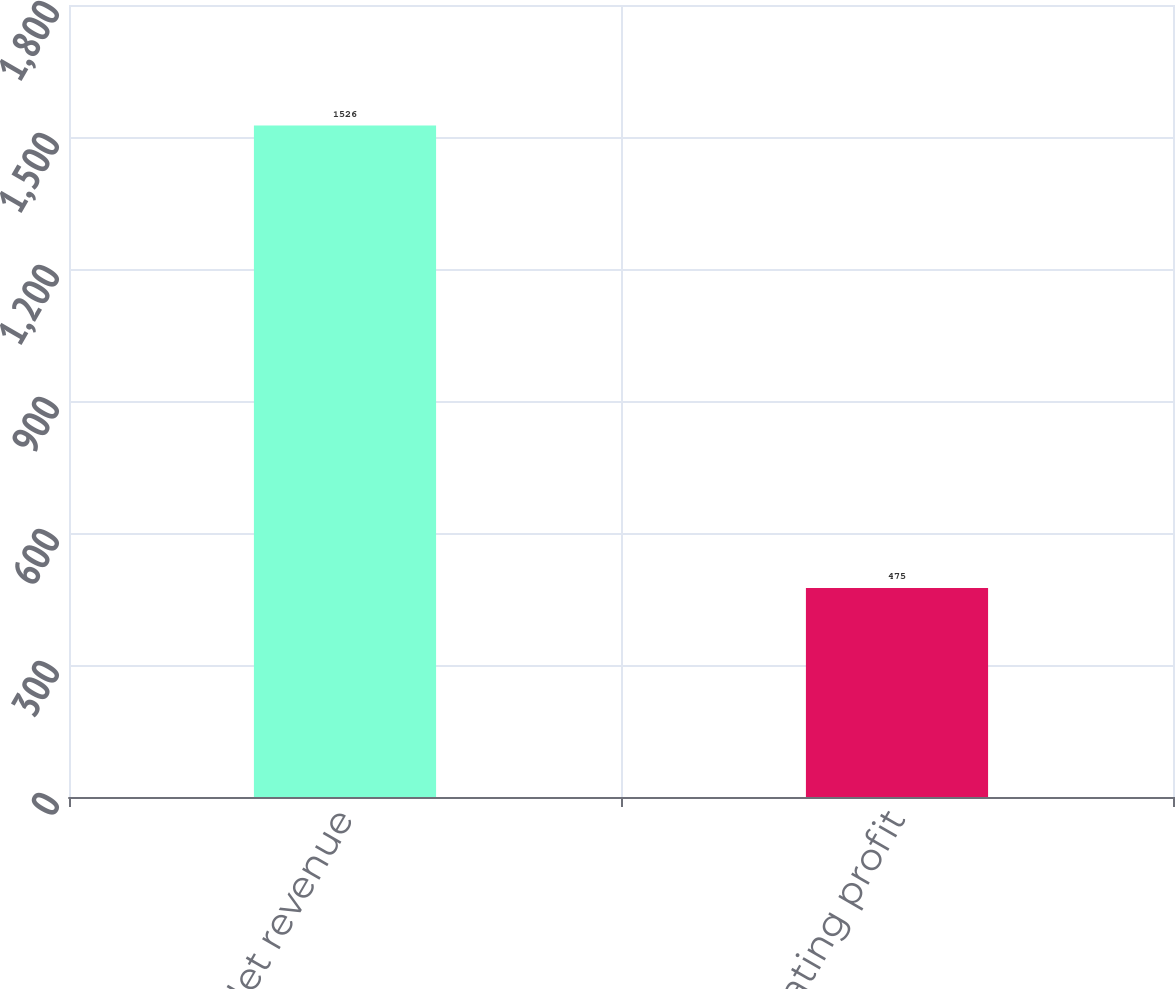<chart> <loc_0><loc_0><loc_500><loc_500><bar_chart><fcel>Net revenue<fcel>Operating profit<nl><fcel>1526<fcel>475<nl></chart> 